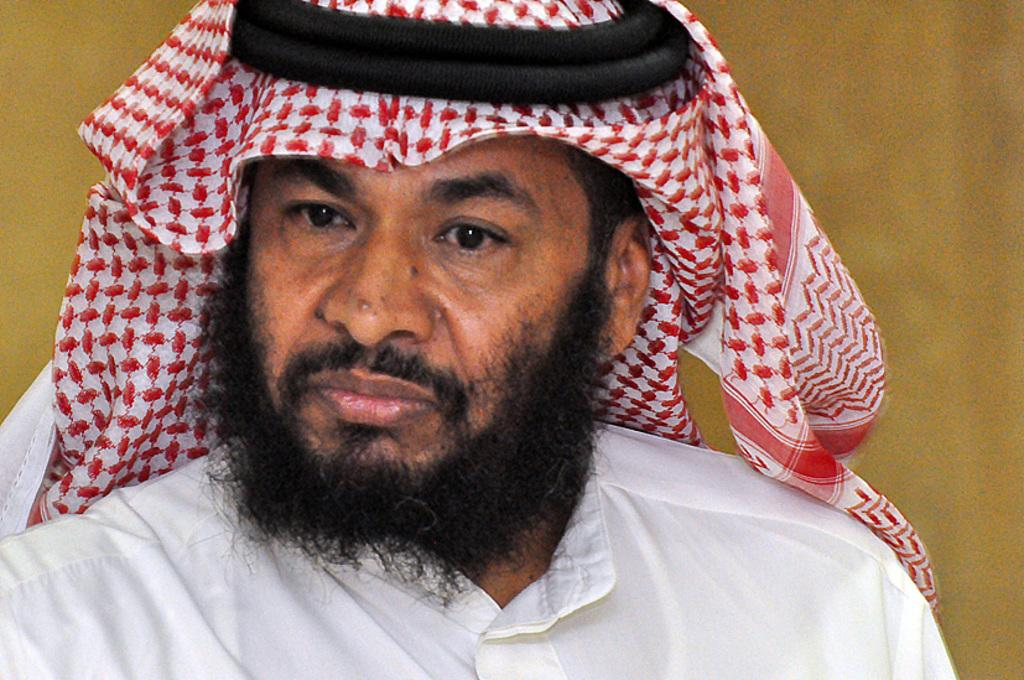Who or what is the main subject of the image? There is a person in the image. What is the person wearing? The person is wearing a white dress and a headscarf. What can be seen in the background of the image? There is a wall in the background of the image. What type of ship can be seen sailing in the background of the image? There is no ship present in the image; it only features a person and a wall in the background. 